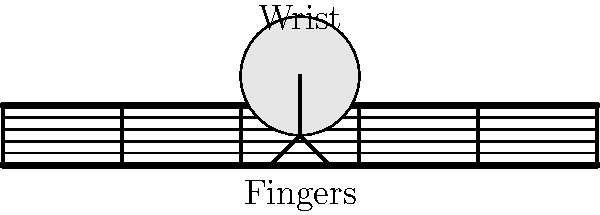Based on the diagram, what is the optimal angle between the wrist and the guitar neck for efficient playing and reduced strain? To determine the optimal angle between the wrist and the guitar neck for efficient playing and reduced strain, we need to consider the following factors:

1. Hand position: The hand should be relaxed and curved naturally over the fretboard.
2. Wrist alignment: The wrist should be as straight as possible to minimize strain.
3. Finger placement: Fingers should be positioned perpendicular to the strings for better control and precision.

Looking at the diagram:
1. The wrist is positioned slightly above the guitar neck.
2. The hand forms a gentle curve from the wrist to the fingertips.
3. The fingers are angled almost perpendicular to the strings.

The optimal angle between the wrist and the guitar neck can be estimated by drawing an imaginary line from the wrist through the base of the fingers. This line should form an angle of approximately 10-15 degrees with the guitar neck.

This slight angle allows for:
a) Natural curvature of the hand
b) Minimal wrist bending
c) Efficient finger placement on the strings

A larger angle would cause excessive wrist bending, leading to strain and potential injuries over time. A smaller angle or completely parallel alignment might limit finger mobility and make it difficult to reach certain chords or notes.
Answer: 10-15 degrees 